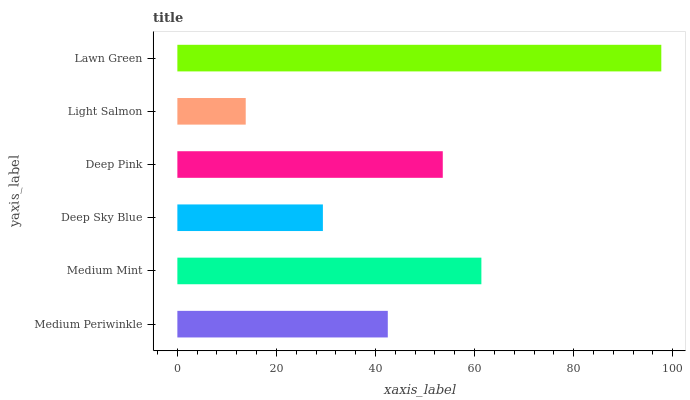Is Light Salmon the minimum?
Answer yes or no. Yes. Is Lawn Green the maximum?
Answer yes or no. Yes. Is Medium Mint the minimum?
Answer yes or no. No. Is Medium Mint the maximum?
Answer yes or no. No. Is Medium Mint greater than Medium Periwinkle?
Answer yes or no. Yes. Is Medium Periwinkle less than Medium Mint?
Answer yes or no. Yes. Is Medium Periwinkle greater than Medium Mint?
Answer yes or no. No. Is Medium Mint less than Medium Periwinkle?
Answer yes or no. No. Is Deep Pink the high median?
Answer yes or no. Yes. Is Medium Periwinkle the low median?
Answer yes or no. Yes. Is Medium Mint the high median?
Answer yes or no. No. Is Lawn Green the low median?
Answer yes or no. No. 